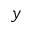Convert formula to latex. <formula><loc_0><loc_0><loc_500><loc_500>y</formula> 